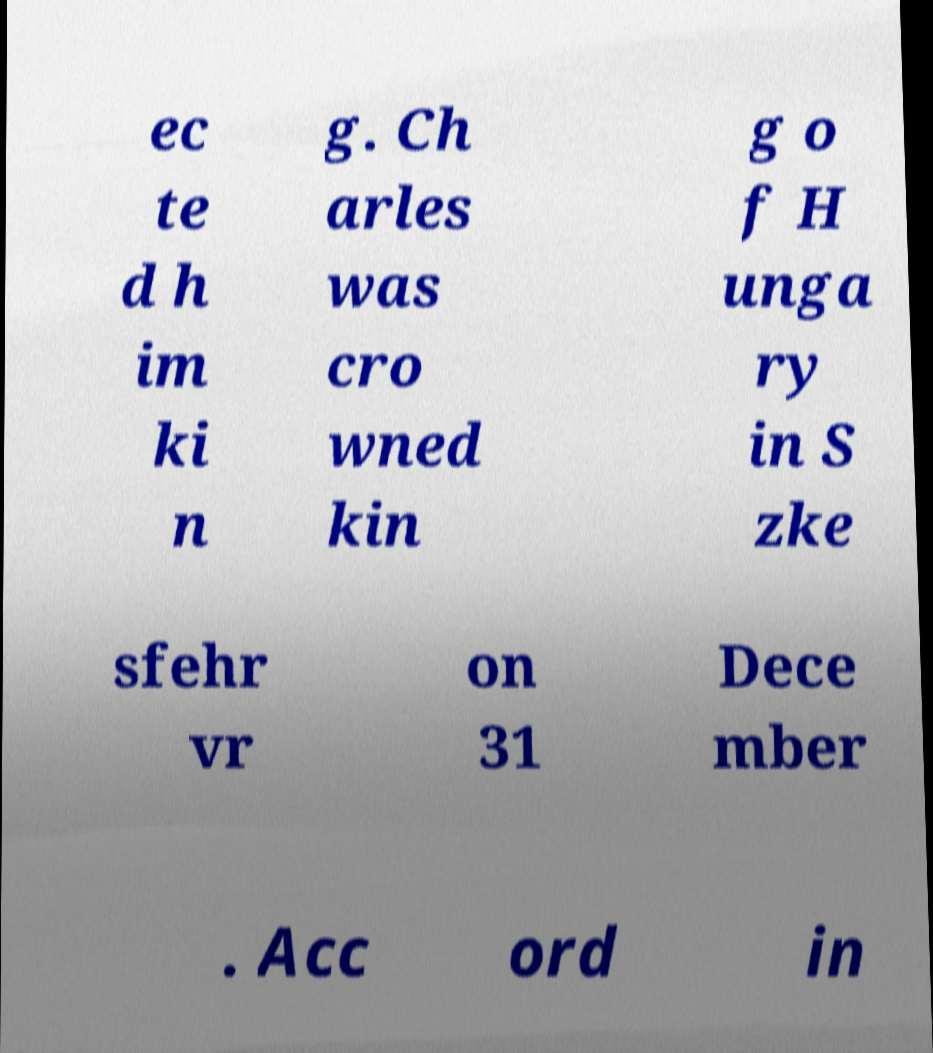Please read and relay the text visible in this image. What does it say? ec te d h im ki n g. Ch arles was cro wned kin g o f H unga ry in S zke sfehr vr on 31 Dece mber . Acc ord in 